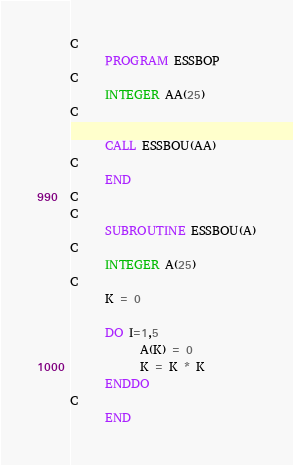<code> <loc_0><loc_0><loc_500><loc_500><_FORTRAN_>C
      PROGRAM ESSBOP
C
      INTEGER AA(25)
C      
      
      CALL ESSBOU(AA)
C
      END
C
C
      SUBROUTINE ESSBOU(A)
C
      INTEGER A(25)
C
      K = 0

      DO I=1,5
            A(K) = 0
            K = K * K
      ENDDO
C
      END
</code> 